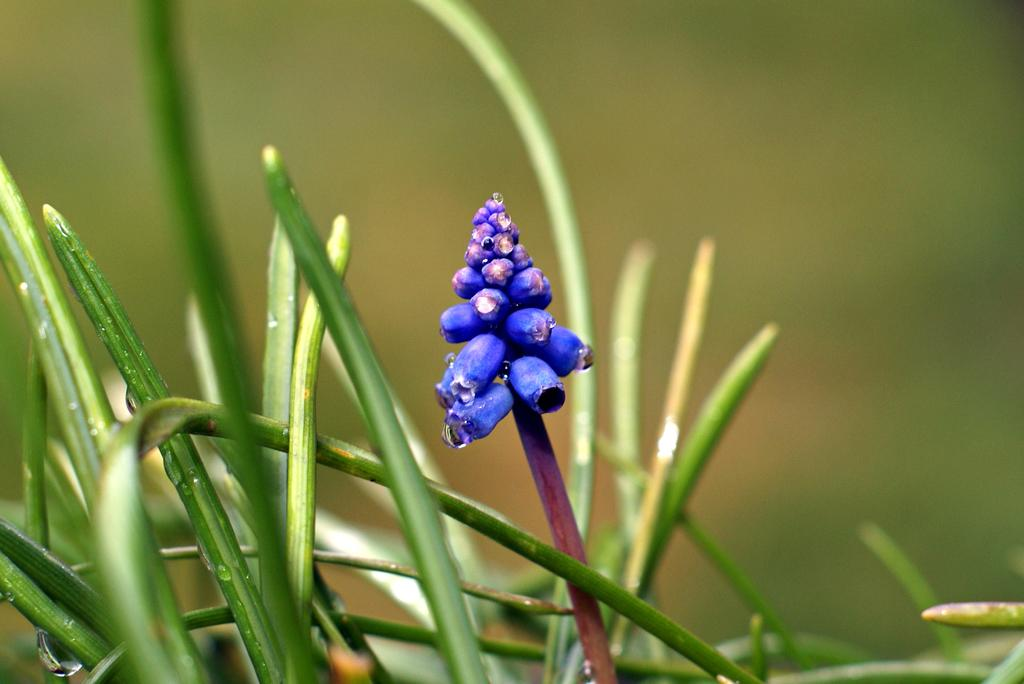What is present in the image? There is a plant in the image. Can you describe the background of the image? The background of the image is blurred. What type of oatmeal is being served in the crib in the image? There is no crib or oatmeal present in the image; it features a plant with a blurred background. 